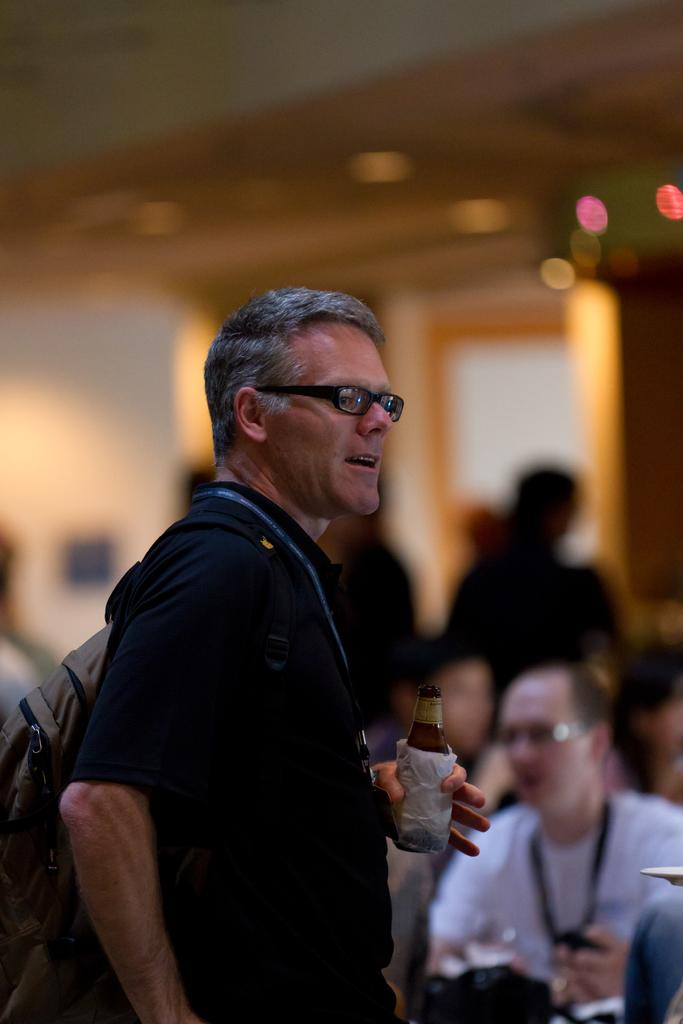What is the main subject of the picture? The main subject of the picture is a man. What is the man wearing on his back? The man is wearing a backpack. What is the man holding in his hand? The man is holding a bottle in his hand. What can be seen on the man's chest? The man is wearing an ID card. What is the man wearing on his face? The man is wearing spectacles. Can you describe the background of the image? The background of the man is blurred. How many apples are on the man's head in the image? There are no apples present on the man's head in the image. What type of plastic material is visible in the image? There is no plastic material visible in the image. 